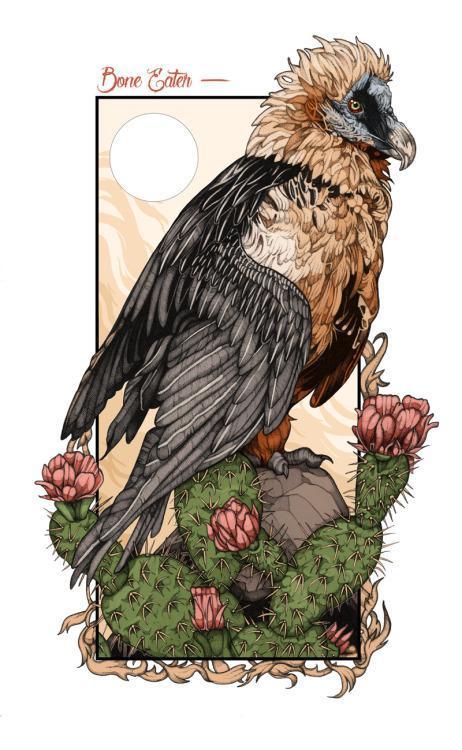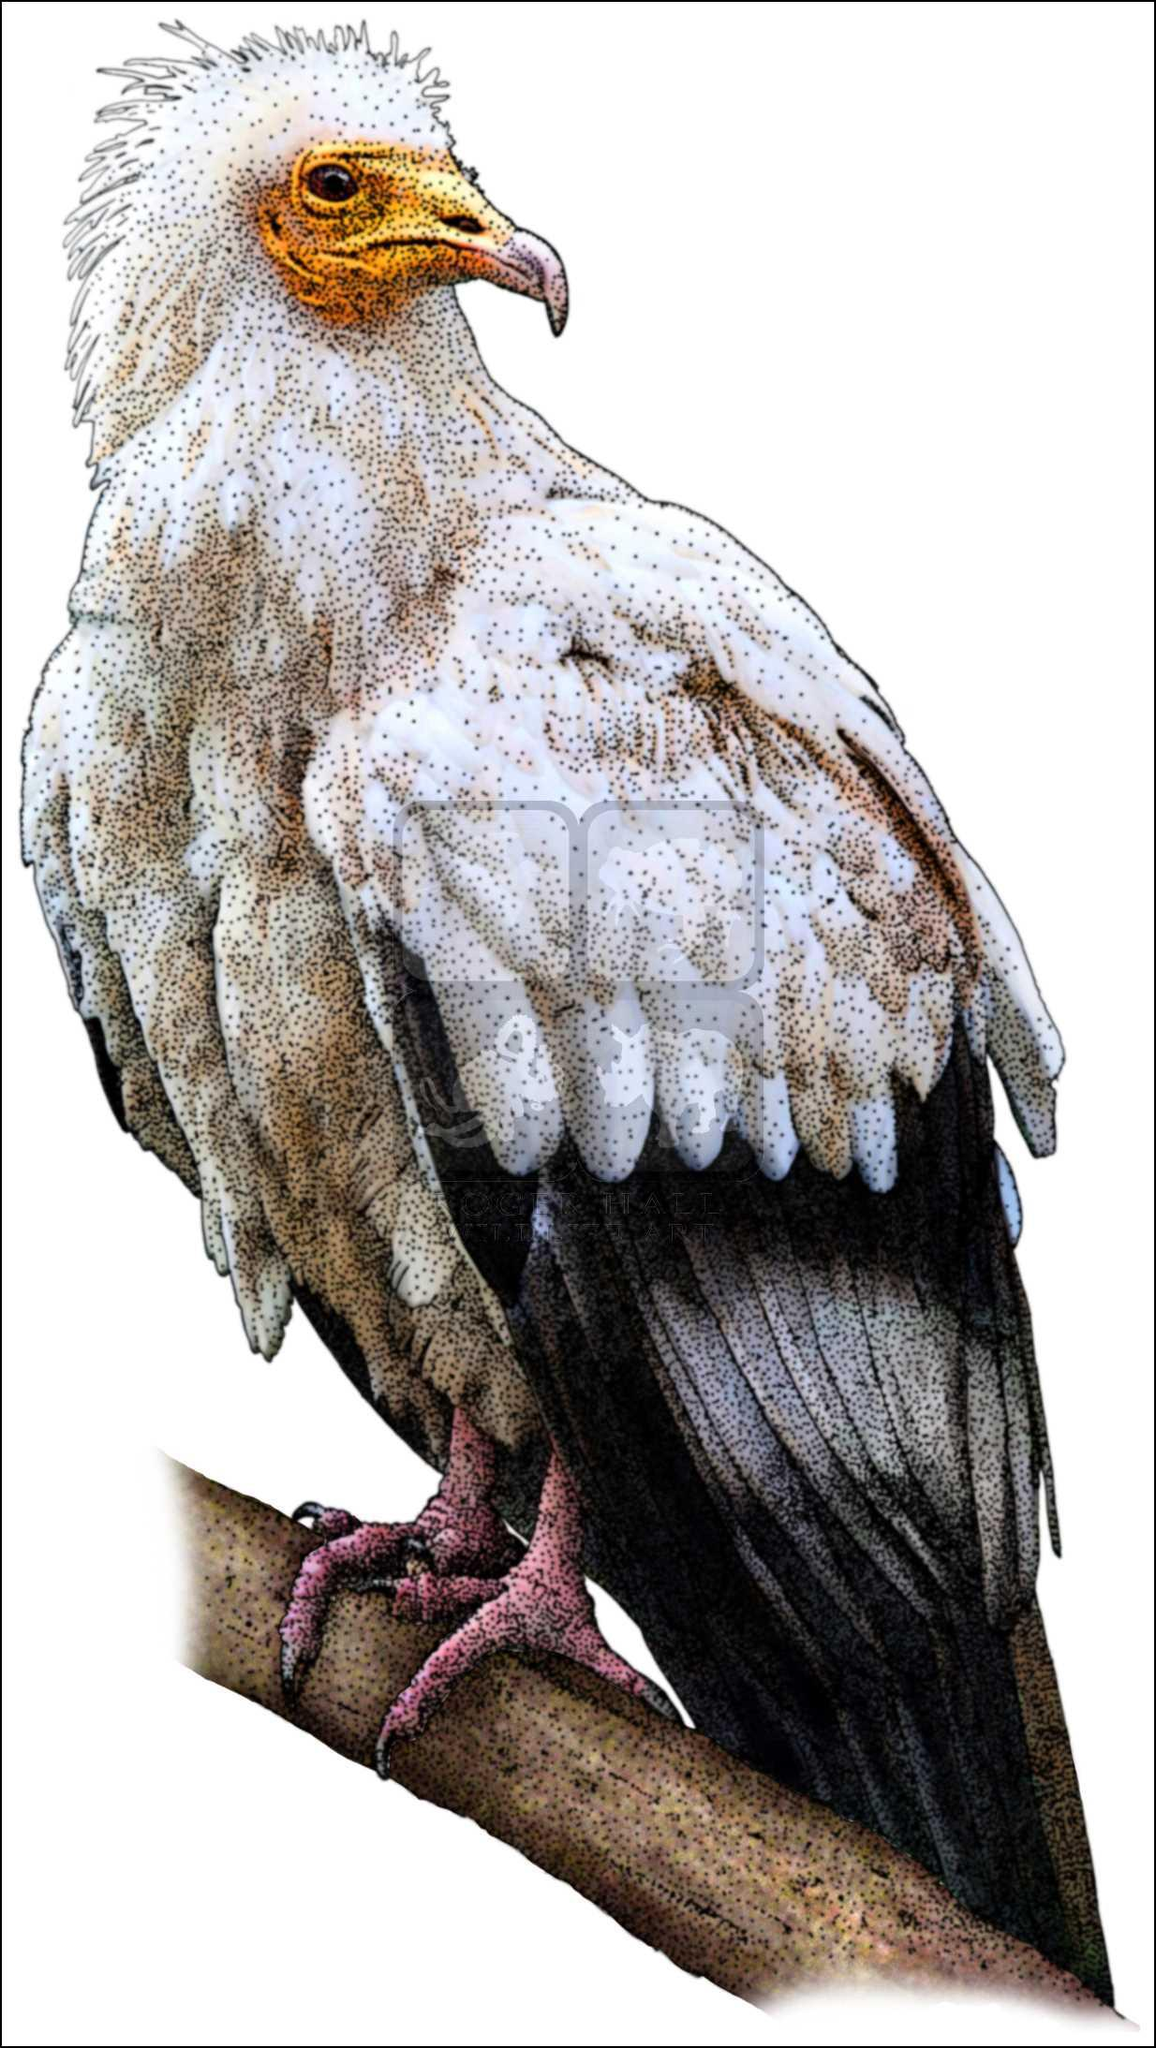The first image is the image on the left, the second image is the image on the right. Evaluate the accuracy of this statement regarding the images: "There are 2 birds.". Is it true? Answer yes or no. Yes. 